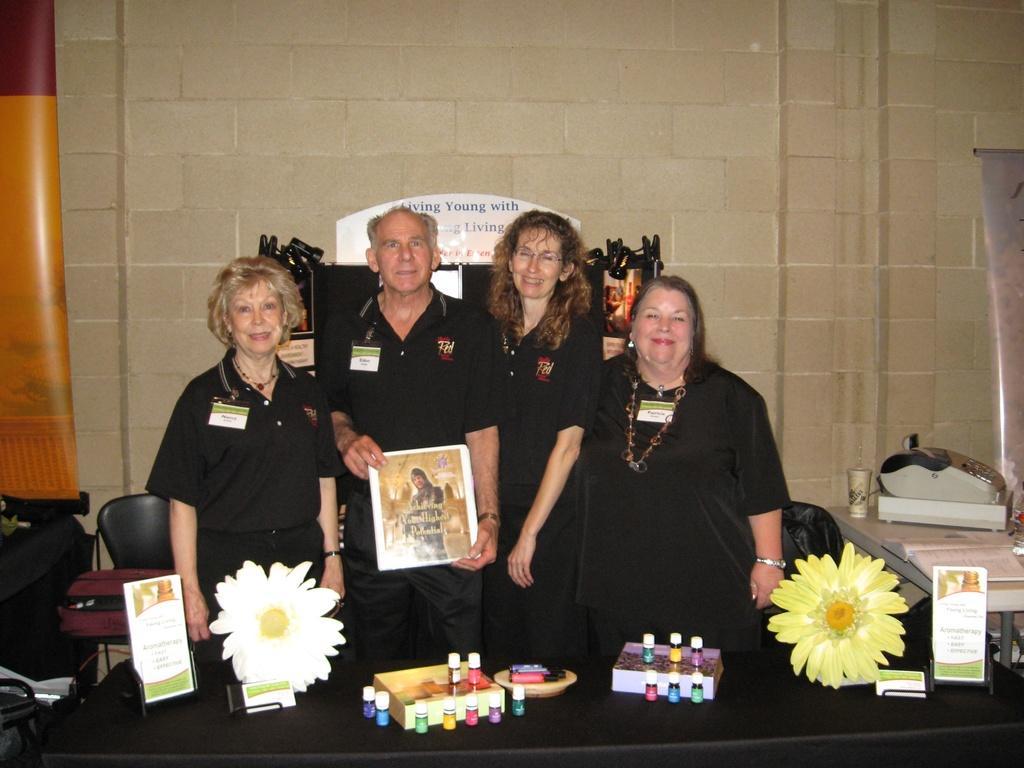Please provide a concise description of this image. In the image there is an old man and three woman standing in front of table in black dress, there are flowers,perfume bottles on the table and the old man is holding a photograph, on the right side there is another table with book on it and behind them there is a wall with a chair on the left side. 